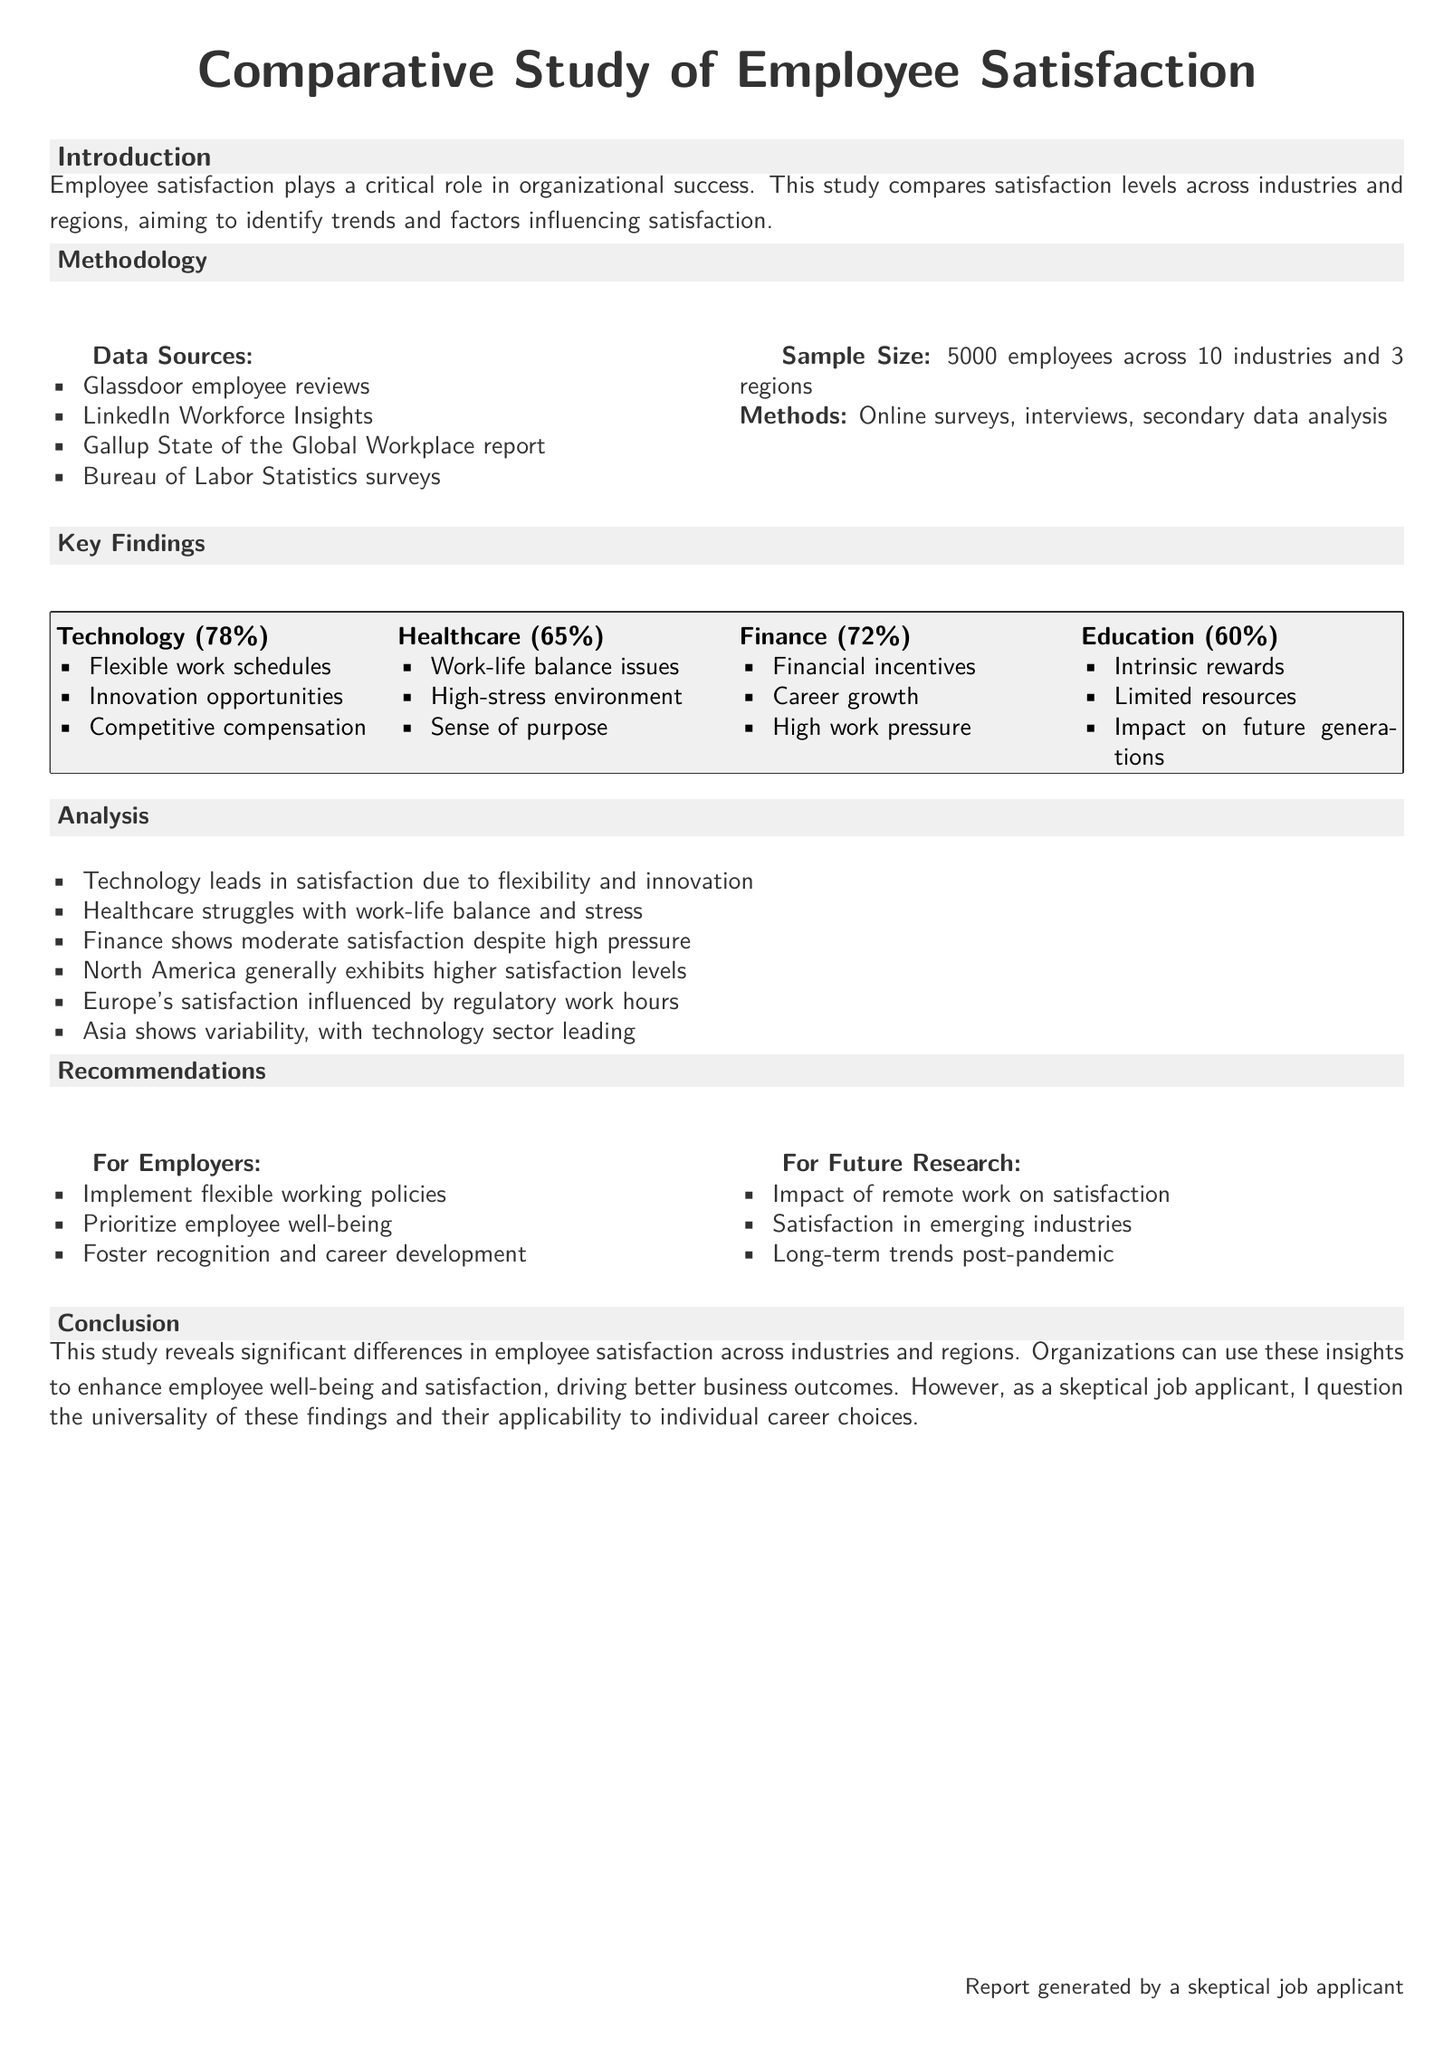What is the total sample size of the study? The sample size is mentioned in the Methodology section, which states 5000 employees across 10 industries and 3 regions.
Answer: 5000 Which industry has the highest employee satisfaction percentage? The Key Findings section indicates that Technology has the highest employee satisfaction at 78%.
Answer: Technology (78%) What percentage of employees in Healthcare reported satisfaction? In the Key Findings section, Healthcare's satisfaction level is noted to be 65%.
Answer: 65% What major issue does the Healthcare sector face according to the findings? The Key Findings section lists work-life balance issues as a significant problem for Healthcare employees.
Answer: Work-life balance issues Which region exhibits generally higher satisfaction levels? The Analysis section states that North America generally exhibits higher satisfaction levels compared to other regions.
Answer: North America What recommendation is made for employers regarding work policies? In the Recommendations section for Employers, it suggests implementing flexible working policies.
Answer: Implement flexible working policies What aspect does the study suggest for future research related to satisfaction? The Recommendations section advises on researching the impact of remote work on satisfaction as a future research topic.
Answer: Impact of remote work on satisfaction How many industries are covered in the study? The Methodology section mentions the study covers a total of 10 industries.
Answer: 10 industries Which publication is listed as a data source? The Methodology section lists various sources, and the Gallup State of the Global Workplace report is one of them.
Answer: Gallup State of the Global Workplace report 